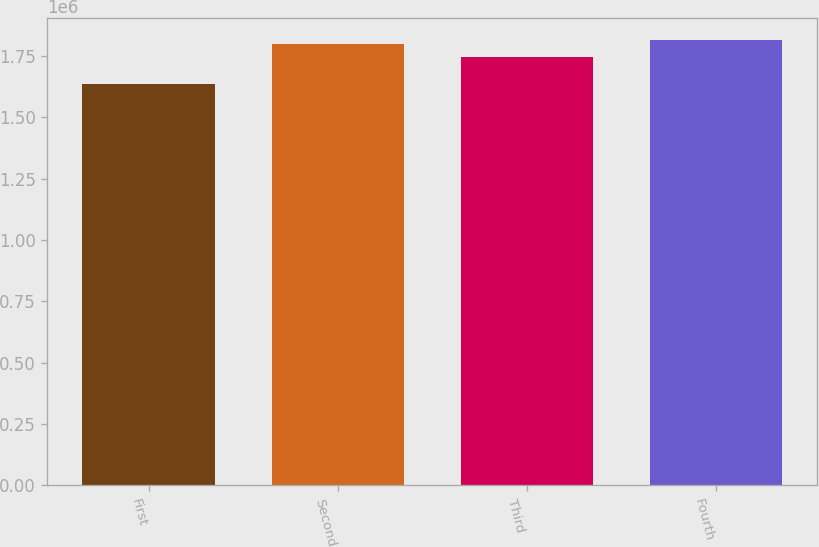<chart> <loc_0><loc_0><loc_500><loc_500><bar_chart><fcel>First<fcel>Second<fcel>Third<fcel>Fourth<nl><fcel>1.63767e+06<fcel>1.79809e+06<fcel>1.7474e+06<fcel>1.81522e+06<nl></chart> 